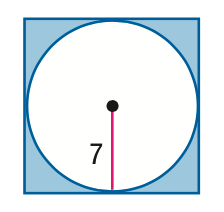Question: Find the area of the shaded region. Assume that the polygon is regular unless otherwise stated. Round to the nearest tenth.
Choices:
A. 42.1
B. 104.9
C. 153.9
D. 196
Answer with the letter. Answer: A 